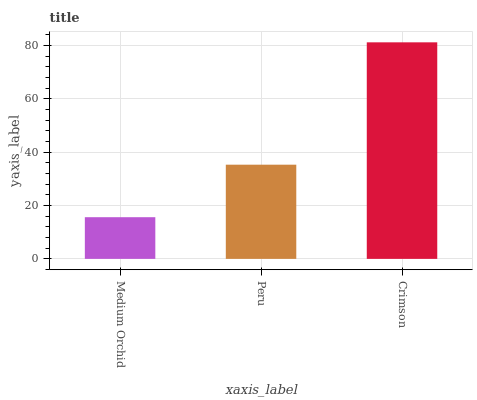Is Medium Orchid the minimum?
Answer yes or no. Yes. Is Crimson the maximum?
Answer yes or no. Yes. Is Peru the minimum?
Answer yes or no. No. Is Peru the maximum?
Answer yes or no. No. Is Peru greater than Medium Orchid?
Answer yes or no. Yes. Is Medium Orchid less than Peru?
Answer yes or no. Yes. Is Medium Orchid greater than Peru?
Answer yes or no. No. Is Peru less than Medium Orchid?
Answer yes or no. No. Is Peru the high median?
Answer yes or no. Yes. Is Peru the low median?
Answer yes or no. Yes. Is Crimson the high median?
Answer yes or no. No. Is Medium Orchid the low median?
Answer yes or no. No. 